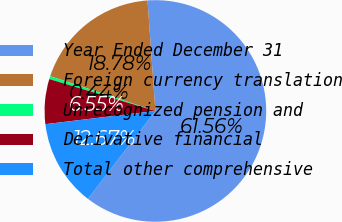Convert chart. <chart><loc_0><loc_0><loc_500><loc_500><pie_chart><fcel>Year Ended December 31<fcel>Foreign currency translation<fcel>Unrecognized pension and<fcel>Derivative financial<fcel>Total other comprehensive<nl><fcel>61.56%<fcel>18.78%<fcel>0.44%<fcel>6.55%<fcel>12.67%<nl></chart> 